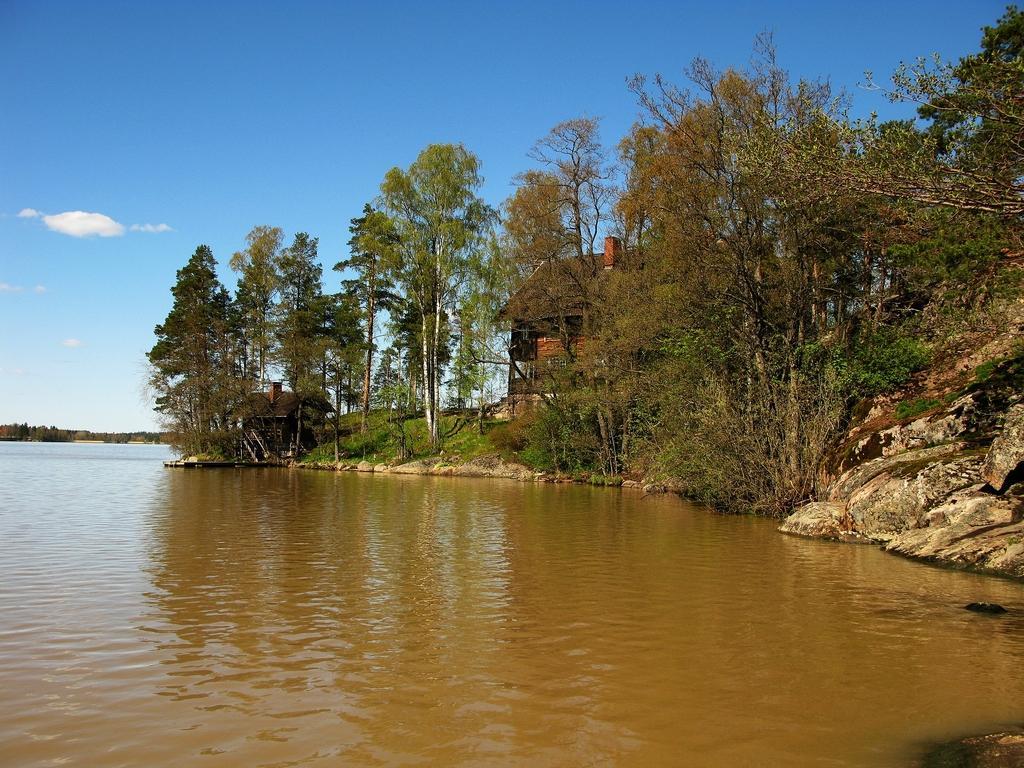Describe this image in one or two sentences. In this image in front there is water. In the background of the image there are houses, trees, rocks. At the top of the image there is sky. 